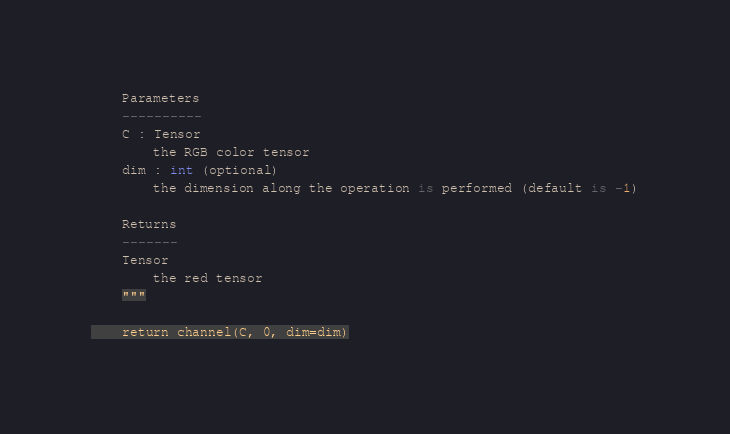<code> <loc_0><loc_0><loc_500><loc_500><_Python_>    Parameters
    ----------
    C : Tensor
        the RGB color tensor
    dim : int (optional)
        the dimension along the operation is performed (default is -1)

    Returns
    -------
    Tensor
        the red tensor
    """

    return channel(C, 0, dim=dim)
</code> 